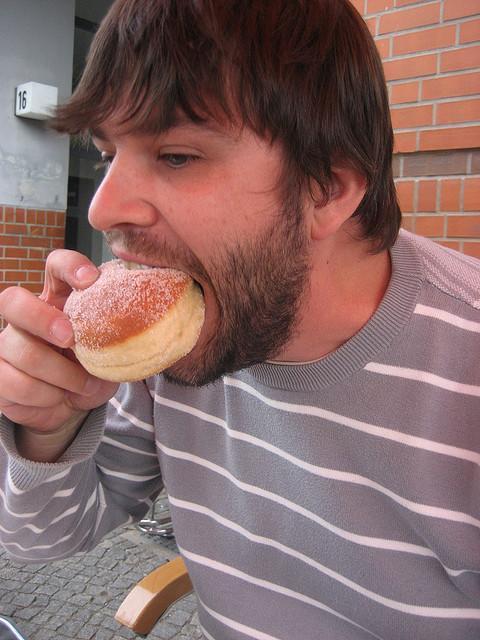How many birds are looking at the camera?
Give a very brief answer. 0. 